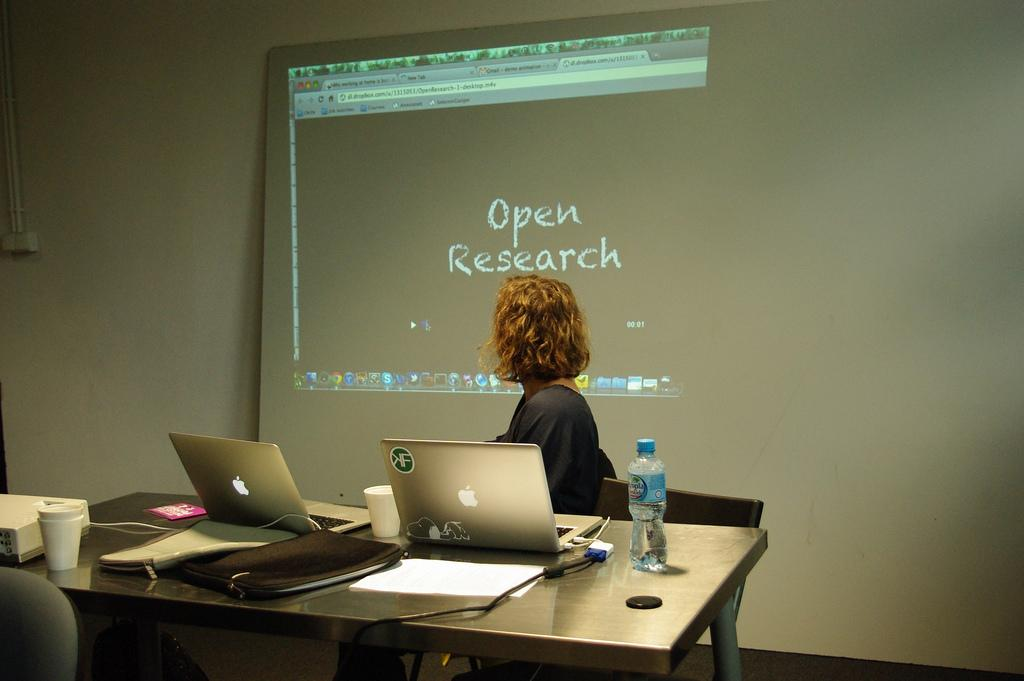What is the woman doing in the image? The woman is sitting at the table in the image. What objects can be seen on the table? There are laptops, a glass, a water bottle, papers, and bags on the table. What is the woman likely using the laptops for? It is likely that the woman is using the laptops for work or study. What can be seen in the background of the image? There is a screen visible in the background of the image. What type of coach is present in the image? There is no coach present in the image; it features a woman sitting at a table with various objects. 